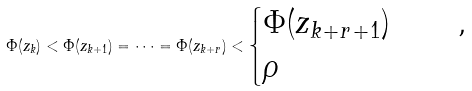Convert formula to latex. <formula><loc_0><loc_0><loc_500><loc_500>\Phi ( z _ { k } ) < \Phi ( z _ { k + 1 } ) = \cdots = \Phi ( z _ { k + r } ) < \begin{cases} \Phi ( z _ { k + r + 1 } ) & \quad , \\ \rho & \quad \end{cases}</formula> 